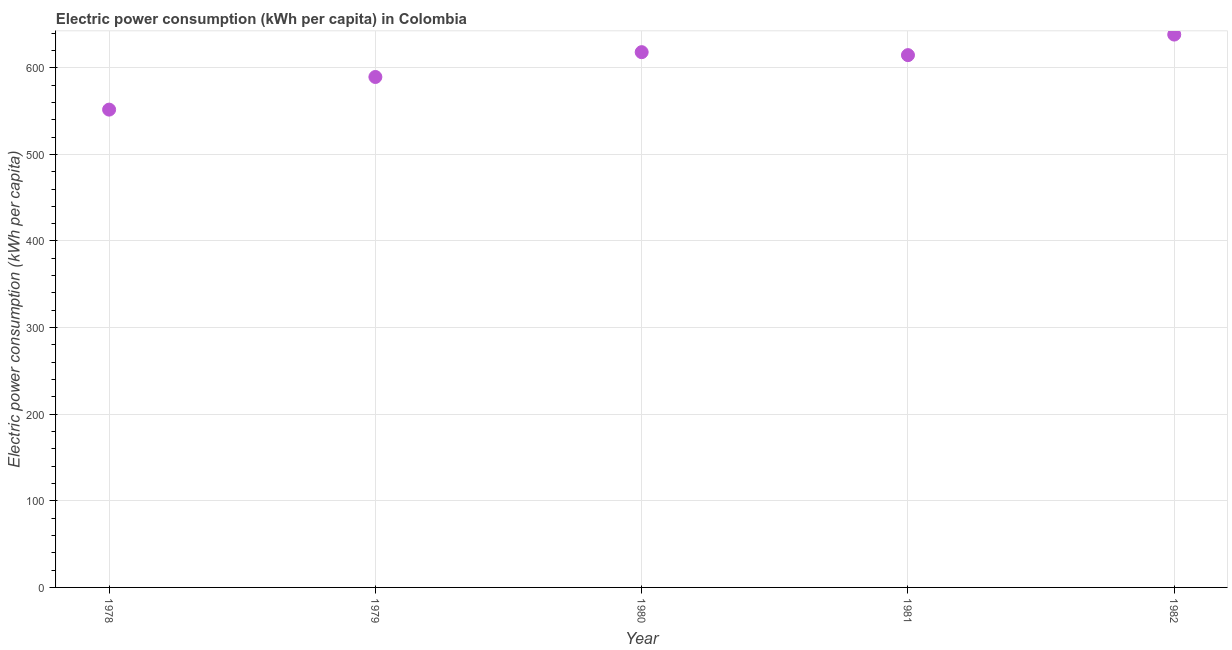What is the electric power consumption in 1981?
Provide a succinct answer. 614.6. Across all years, what is the maximum electric power consumption?
Your response must be concise. 638.33. Across all years, what is the minimum electric power consumption?
Make the answer very short. 551.69. In which year was the electric power consumption minimum?
Provide a succinct answer. 1978. What is the sum of the electric power consumption?
Offer a terse response. 3012.04. What is the difference between the electric power consumption in 1978 and 1979?
Your answer should be very brief. -37.68. What is the average electric power consumption per year?
Ensure brevity in your answer.  602.41. What is the median electric power consumption?
Offer a terse response. 614.6. What is the ratio of the electric power consumption in 1979 to that in 1980?
Offer a terse response. 0.95. What is the difference between the highest and the second highest electric power consumption?
Your answer should be compact. 20.3. Is the sum of the electric power consumption in 1981 and 1982 greater than the maximum electric power consumption across all years?
Provide a short and direct response. Yes. What is the difference between the highest and the lowest electric power consumption?
Provide a succinct answer. 86.64. How many dotlines are there?
Provide a short and direct response. 1. How many years are there in the graph?
Ensure brevity in your answer.  5. Are the values on the major ticks of Y-axis written in scientific E-notation?
Keep it short and to the point. No. Does the graph contain any zero values?
Give a very brief answer. No. What is the title of the graph?
Ensure brevity in your answer.  Electric power consumption (kWh per capita) in Colombia. What is the label or title of the Y-axis?
Offer a terse response. Electric power consumption (kWh per capita). What is the Electric power consumption (kWh per capita) in 1978?
Keep it short and to the point. 551.69. What is the Electric power consumption (kWh per capita) in 1979?
Offer a very short reply. 589.37. What is the Electric power consumption (kWh per capita) in 1980?
Make the answer very short. 618.04. What is the Electric power consumption (kWh per capita) in 1981?
Your answer should be very brief. 614.6. What is the Electric power consumption (kWh per capita) in 1982?
Your answer should be compact. 638.33. What is the difference between the Electric power consumption (kWh per capita) in 1978 and 1979?
Make the answer very short. -37.68. What is the difference between the Electric power consumption (kWh per capita) in 1978 and 1980?
Your answer should be compact. -66.34. What is the difference between the Electric power consumption (kWh per capita) in 1978 and 1981?
Give a very brief answer. -62.91. What is the difference between the Electric power consumption (kWh per capita) in 1978 and 1982?
Provide a short and direct response. -86.64. What is the difference between the Electric power consumption (kWh per capita) in 1979 and 1980?
Make the answer very short. -28.66. What is the difference between the Electric power consumption (kWh per capita) in 1979 and 1981?
Your answer should be compact. -25.23. What is the difference between the Electric power consumption (kWh per capita) in 1979 and 1982?
Make the answer very short. -48.96. What is the difference between the Electric power consumption (kWh per capita) in 1980 and 1981?
Give a very brief answer. 3.43. What is the difference between the Electric power consumption (kWh per capita) in 1980 and 1982?
Your response must be concise. -20.3. What is the difference between the Electric power consumption (kWh per capita) in 1981 and 1982?
Your answer should be very brief. -23.73. What is the ratio of the Electric power consumption (kWh per capita) in 1978 to that in 1979?
Give a very brief answer. 0.94. What is the ratio of the Electric power consumption (kWh per capita) in 1978 to that in 1980?
Offer a very short reply. 0.89. What is the ratio of the Electric power consumption (kWh per capita) in 1978 to that in 1981?
Your answer should be very brief. 0.9. What is the ratio of the Electric power consumption (kWh per capita) in 1978 to that in 1982?
Make the answer very short. 0.86. What is the ratio of the Electric power consumption (kWh per capita) in 1979 to that in 1980?
Your answer should be compact. 0.95. What is the ratio of the Electric power consumption (kWh per capita) in 1979 to that in 1982?
Your answer should be very brief. 0.92. What is the ratio of the Electric power consumption (kWh per capita) in 1981 to that in 1982?
Ensure brevity in your answer.  0.96. 